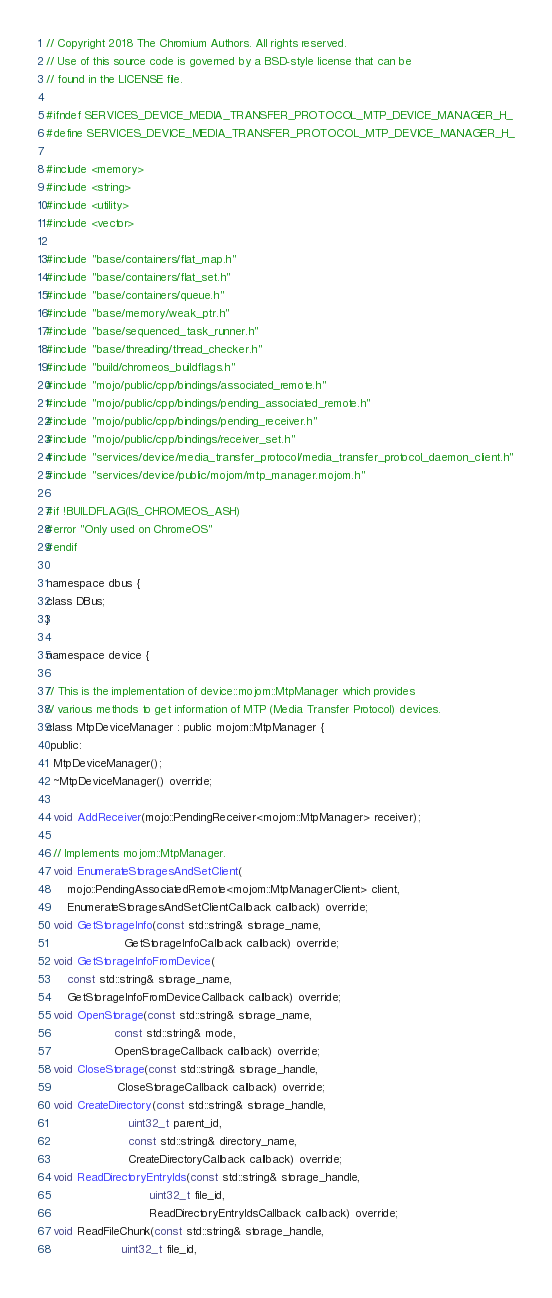<code> <loc_0><loc_0><loc_500><loc_500><_C_>// Copyright 2018 The Chromium Authors. All rights reserved.
// Use of this source code is governed by a BSD-style license that can be
// found in the LICENSE file.

#ifndef SERVICES_DEVICE_MEDIA_TRANSFER_PROTOCOL_MTP_DEVICE_MANAGER_H_
#define SERVICES_DEVICE_MEDIA_TRANSFER_PROTOCOL_MTP_DEVICE_MANAGER_H_

#include <memory>
#include <string>
#include <utility>
#include <vector>

#include "base/containers/flat_map.h"
#include "base/containers/flat_set.h"
#include "base/containers/queue.h"
#include "base/memory/weak_ptr.h"
#include "base/sequenced_task_runner.h"
#include "base/threading/thread_checker.h"
#include "build/chromeos_buildflags.h"
#include "mojo/public/cpp/bindings/associated_remote.h"
#include "mojo/public/cpp/bindings/pending_associated_remote.h"
#include "mojo/public/cpp/bindings/pending_receiver.h"
#include "mojo/public/cpp/bindings/receiver_set.h"
#include "services/device/media_transfer_protocol/media_transfer_protocol_daemon_client.h"
#include "services/device/public/mojom/mtp_manager.mojom.h"

#if !BUILDFLAG(IS_CHROMEOS_ASH)
#error "Only used on ChromeOS"
#endif

namespace dbus {
class DBus;
}

namespace device {

// This is the implementation of device::mojom::MtpManager which provides
// various methods to get information of MTP (Media Transfer Protocol) devices.
class MtpDeviceManager : public mojom::MtpManager {
 public:
  MtpDeviceManager();
  ~MtpDeviceManager() override;

  void AddReceiver(mojo::PendingReceiver<mojom::MtpManager> receiver);

  // Implements mojom::MtpManager.
  void EnumerateStoragesAndSetClient(
      mojo::PendingAssociatedRemote<mojom::MtpManagerClient> client,
      EnumerateStoragesAndSetClientCallback callback) override;
  void GetStorageInfo(const std::string& storage_name,
                      GetStorageInfoCallback callback) override;
  void GetStorageInfoFromDevice(
      const std::string& storage_name,
      GetStorageInfoFromDeviceCallback callback) override;
  void OpenStorage(const std::string& storage_name,
                   const std::string& mode,
                   OpenStorageCallback callback) override;
  void CloseStorage(const std::string& storage_handle,
                    CloseStorageCallback callback) override;
  void CreateDirectory(const std::string& storage_handle,
                       uint32_t parent_id,
                       const std::string& directory_name,
                       CreateDirectoryCallback callback) override;
  void ReadDirectoryEntryIds(const std::string& storage_handle,
                             uint32_t file_id,
                             ReadDirectoryEntryIdsCallback callback) override;
  void ReadFileChunk(const std::string& storage_handle,
                     uint32_t file_id,</code> 